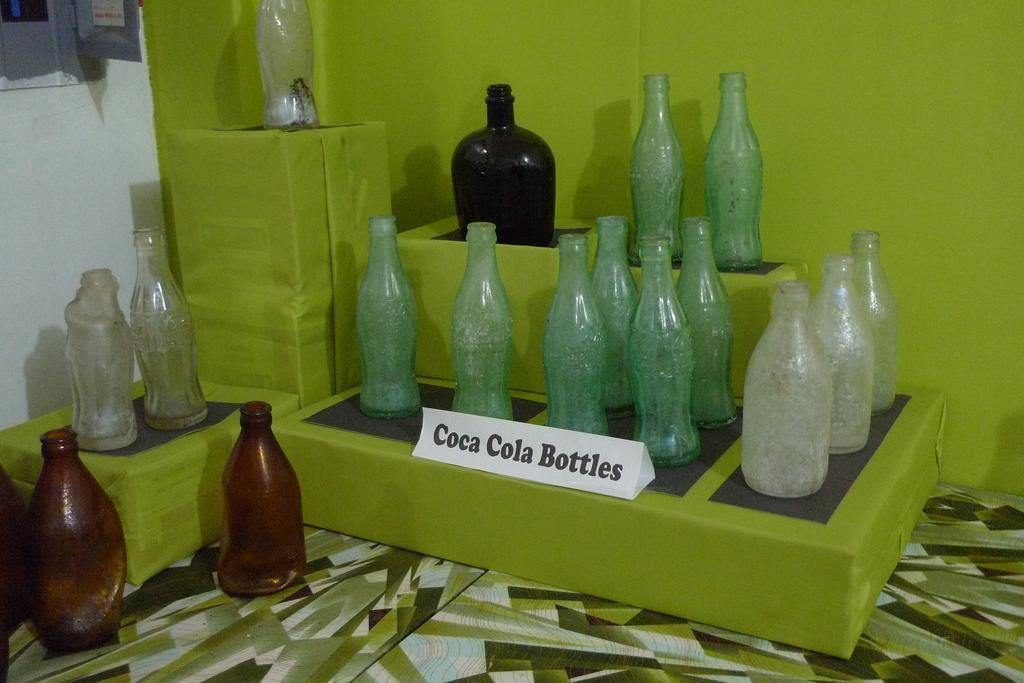Provide a one-sentence caption for the provided image. A display of old coca cola bottles on some green boxes. 